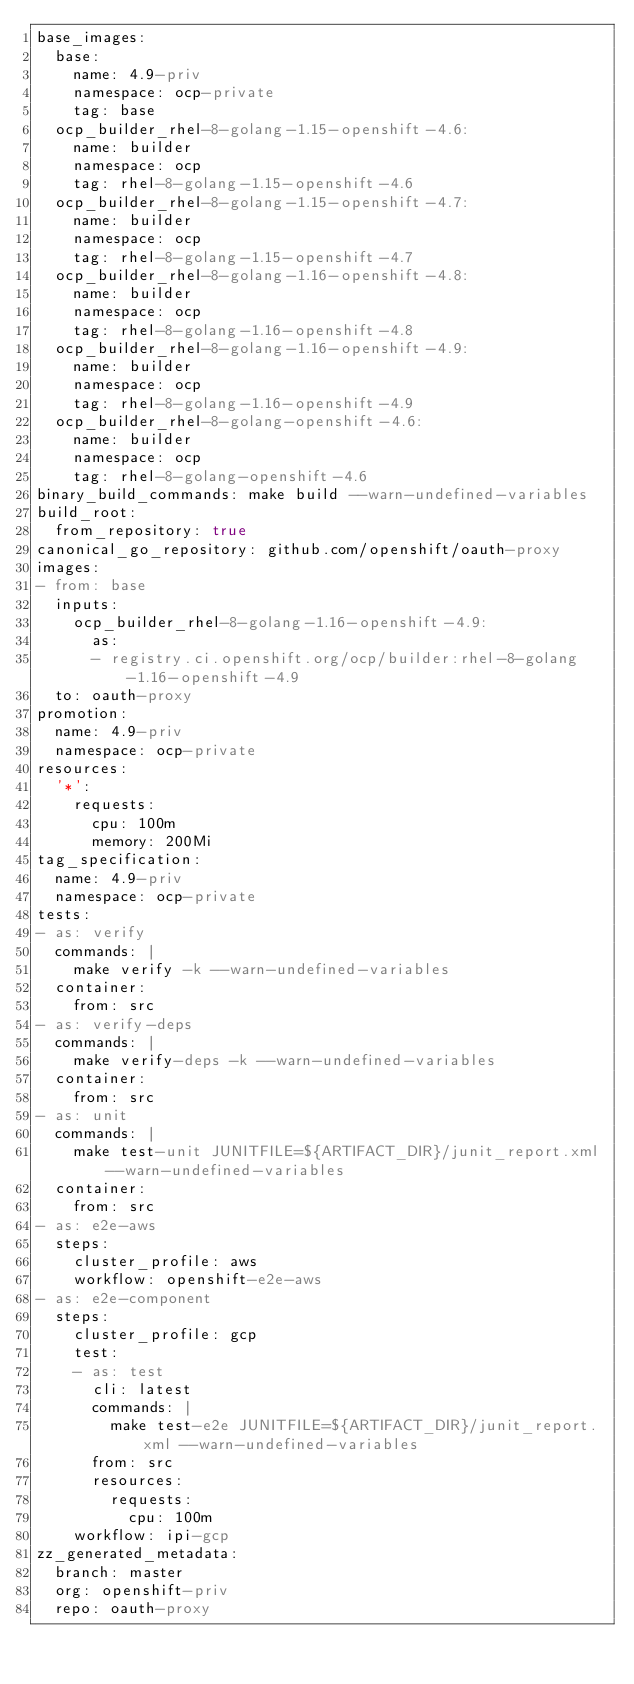Convert code to text. <code><loc_0><loc_0><loc_500><loc_500><_YAML_>base_images:
  base:
    name: 4.9-priv
    namespace: ocp-private
    tag: base
  ocp_builder_rhel-8-golang-1.15-openshift-4.6:
    name: builder
    namespace: ocp
    tag: rhel-8-golang-1.15-openshift-4.6
  ocp_builder_rhel-8-golang-1.15-openshift-4.7:
    name: builder
    namespace: ocp
    tag: rhel-8-golang-1.15-openshift-4.7
  ocp_builder_rhel-8-golang-1.16-openshift-4.8:
    name: builder
    namespace: ocp
    tag: rhel-8-golang-1.16-openshift-4.8
  ocp_builder_rhel-8-golang-1.16-openshift-4.9:
    name: builder
    namespace: ocp
    tag: rhel-8-golang-1.16-openshift-4.9
  ocp_builder_rhel-8-golang-openshift-4.6:
    name: builder
    namespace: ocp
    tag: rhel-8-golang-openshift-4.6
binary_build_commands: make build --warn-undefined-variables
build_root:
  from_repository: true
canonical_go_repository: github.com/openshift/oauth-proxy
images:
- from: base
  inputs:
    ocp_builder_rhel-8-golang-1.16-openshift-4.9:
      as:
      - registry.ci.openshift.org/ocp/builder:rhel-8-golang-1.16-openshift-4.9
  to: oauth-proxy
promotion:
  name: 4.9-priv
  namespace: ocp-private
resources:
  '*':
    requests:
      cpu: 100m
      memory: 200Mi
tag_specification:
  name: 4.9-priv
  namespace: ocp-private
tests:
- as: verify
  commands: |
    make verify -k --warn-undefined-variables
  container:
    from: src
- as: verify-deps
  commands: |
    make verify-deps -k --warn-undefined-variables
  container:
    from: src
- as: unit
  commands: |
    make test-unit JUNITFILE=${ARTIFACT_DIR}/junit_report.xml --warn-undefined-variables
  container:
    from: src
- as: e2e-aws
  steps:
    cluster_profile: aws
    workflow: openshift-e2e-aws
- as: e2e-component
  steps:
    cluster_profile: gcp
    test:
    - as: test
      cli: latest
      commands: |
        make test-e2e JUNITFILE=${ARTIFACT_DIR}/junit_report.xml --warn-undefined-variables
      from: src
      resources:
        requests:
          cpu: 100m
    workflow: ipi-gcp
zz_generated_metadata:
  branch: master
  org: openshift-priv
  repo: oauth-proxy
</code> 